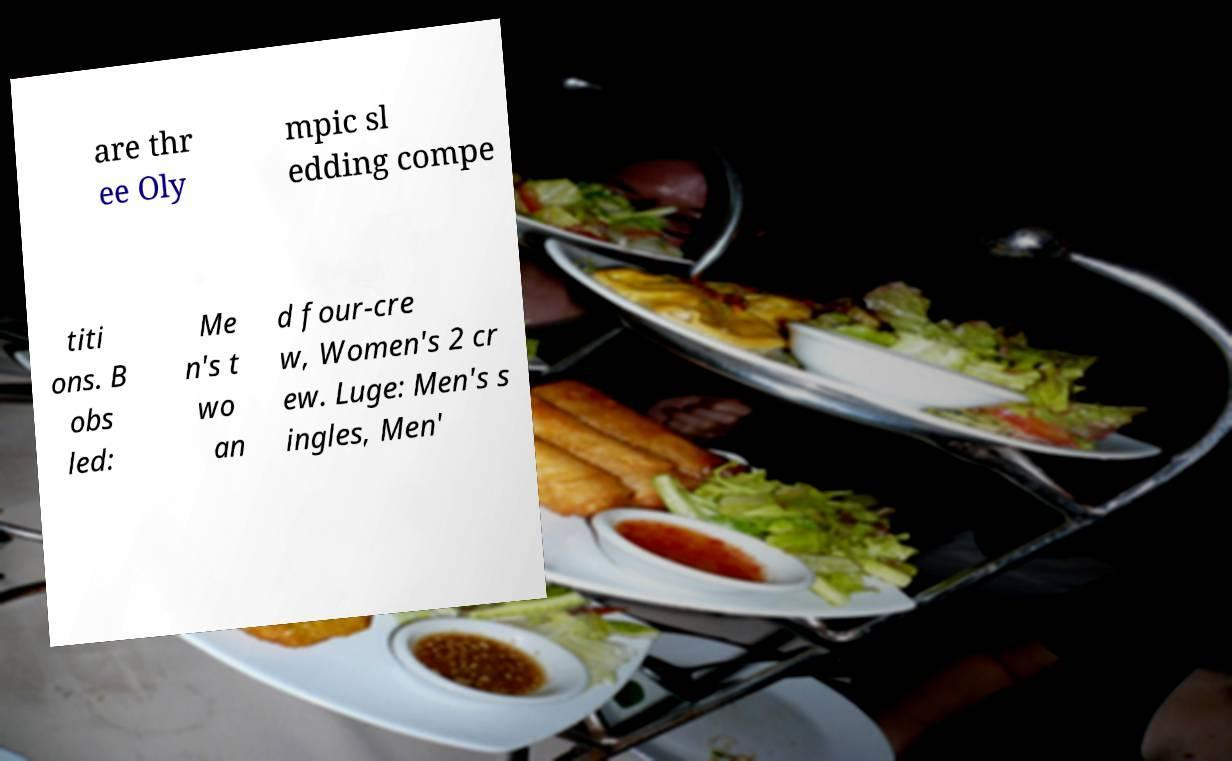Please identify and transcribe the text found in this image. are thr ee Oly mpic sl edding compe titi ons. B obs led: Me n's t wo an d four-cre w, Women's 2 cr ew. Luge: Men's s ingles, Men' 